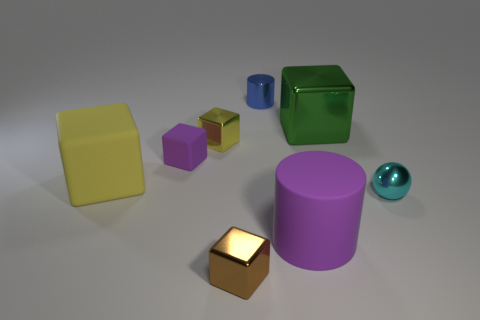There is a shiny thing that is to the left of the blue metallic object and behind the large cylinder; how big is it?
Keep it short and to the point. Small. Are there more metallic balls that are behind the tiny yellow block than large green shiny balls?
Offer a very short reply. No. What number of cylinders are either yellow matte things or yellow metallic things?
Offer a very short reply. 0. There is a small shiny object that is both on the right side of the brown metallic block and to the left of the green thing; what shape is it?
Your response must be concise. Cylinder. Are there an equal number of large yellow objects behind the tiny brown metallic object and rubber things behind the small purple object?
Provide a succinct answer. No. How many objects are small cylinders or small yellow rubber objects?
Your response must be concise. 1. What is the color of the shiny block that is the same size as the purple rubber cylinder?
Make the answer very short. Green. How many things are big objects to the right of the brown object or yellow cubes that are behind the purple cube?
Make the answer very short. 3. Are there the same number of large rubber cylinders on the right side of the large green metal block and brown metal blocks?
Provide a succinct answer. No. Is the size of the block that is in front of the large purple rubber thing the same as the yellow object that is right of the big yellow thing?
Make the answer very short. Yes. 